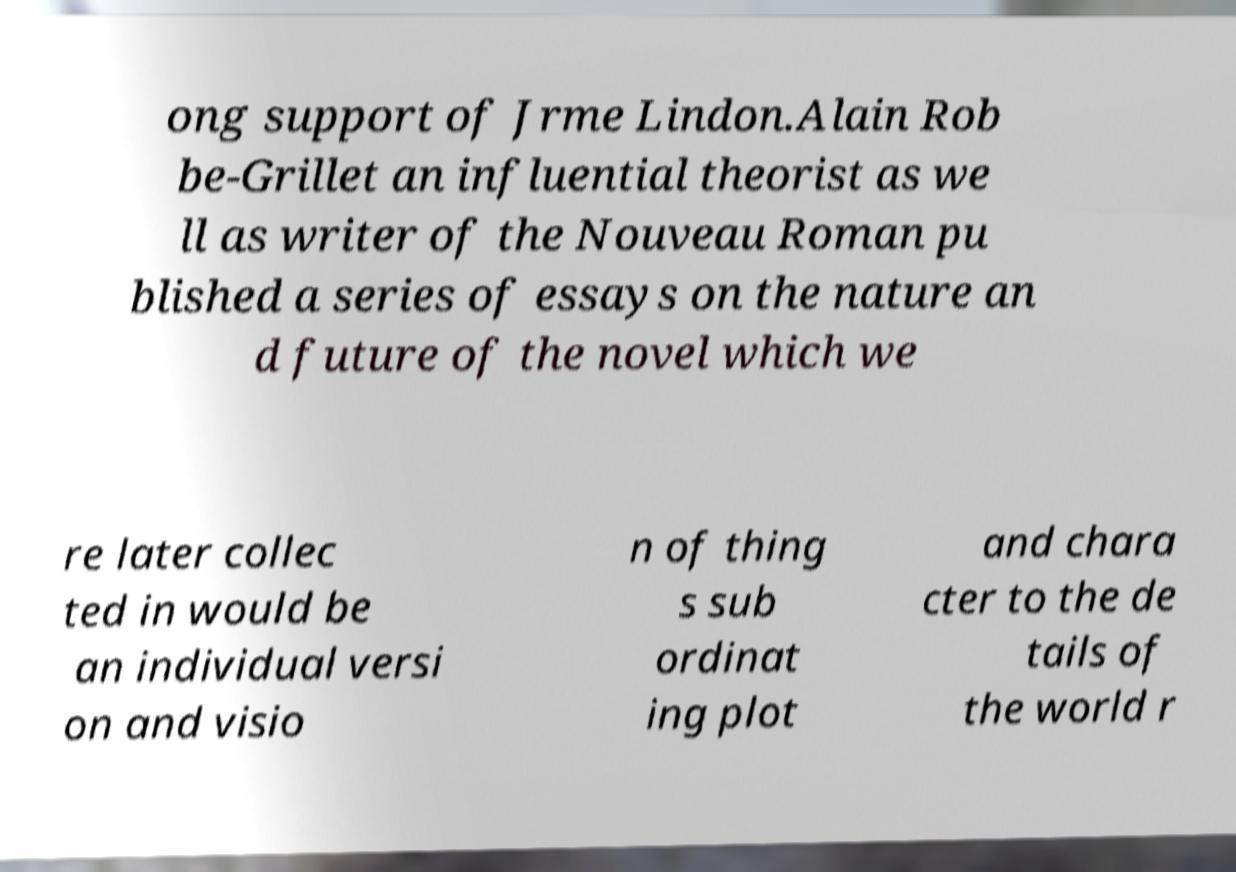I need the written content from this picture converted into text. Can you do that? ong support of Jrme Lindon.Alain Rob be-Grillet an influential theorist as we ll as writer of the Nouveau Roman pu blished a series of essays on the nature an d future of the novel which we re later collec ted in would be an individual versi on and visio n of thing s sub ordinat ing plot and chara cter to the de tails of the world r 